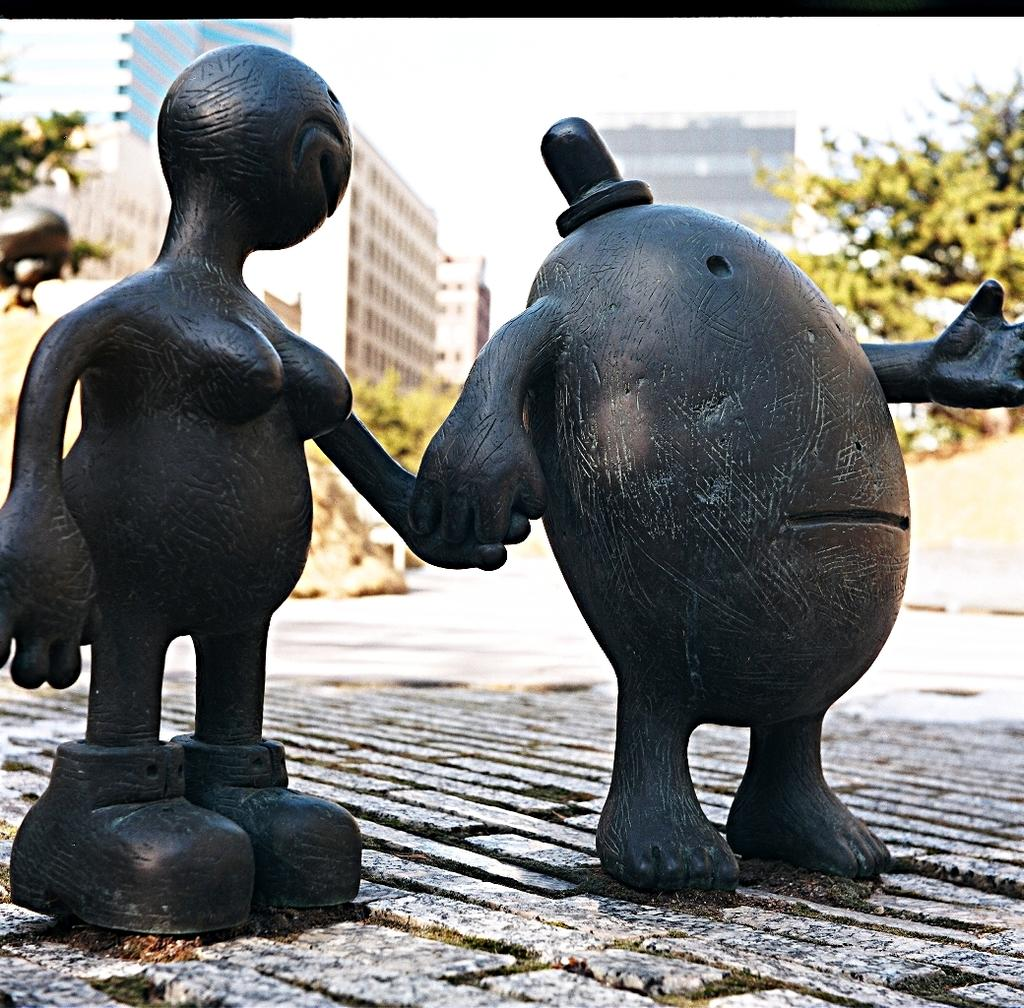How many sculptures are present in the image? There are two sculptures in the image. What are the subjects of the sculptures? One sculpture is of a person, and the other sculpture is egg-shaped. What can be seen in the background of the image? There are trees, buildings, and the sky visible in the background of the image. What type of coach is present in the image? There is no coach present in the image; it features two sculptures and a background with trees, buildings, and the sky. What wish does the egg-shaped sculpture grant in the image? There is no mention of wishes or magic in the image; it simply depicts two sculptures and their surroundings. 